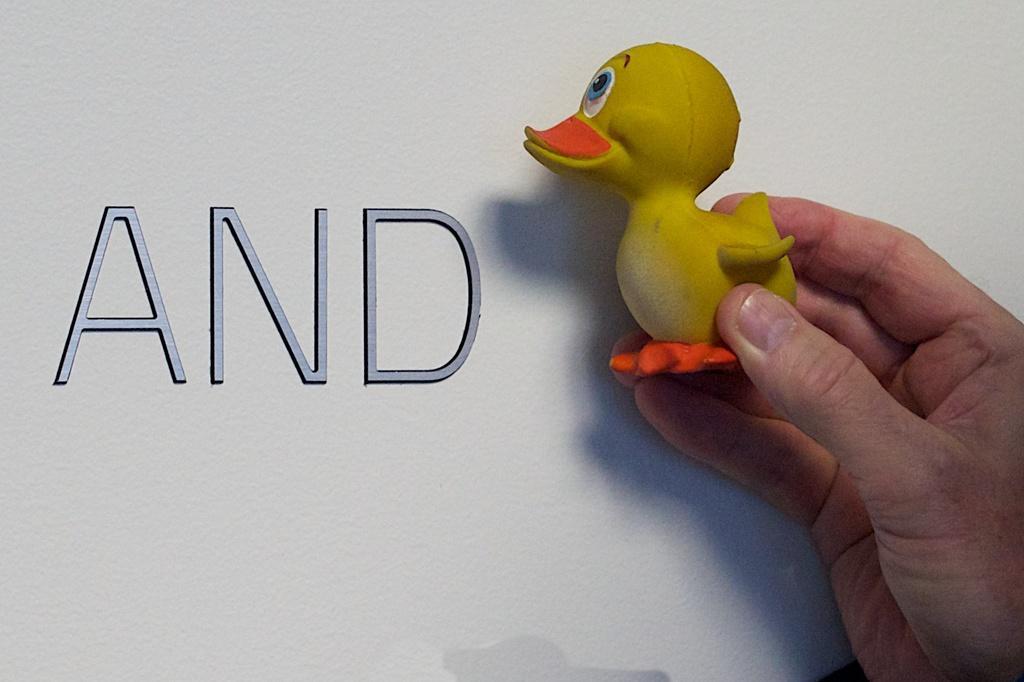What is the person's hand holding in the image? There is a person's hand holding a duck toy in the image. What else can be seen in the image besides the hand and the duck toy? There is some text present in the image. What type of tax is being discussed in the image? There is no discussion of tax in the image; it features a person's hand holding a duck toy and some text. How much wax is visible in the image? There is no wax present in the image. 